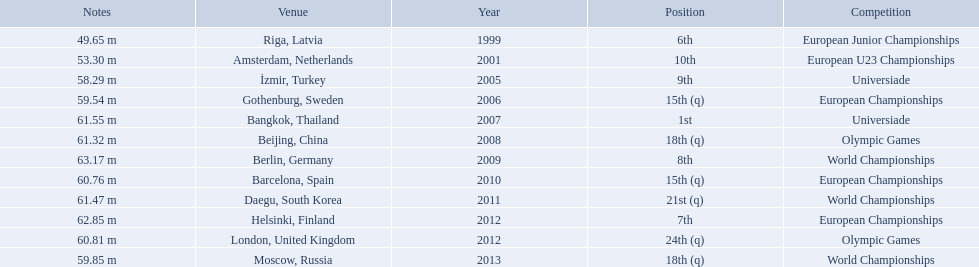What are all the competitions? European Junior Championships, European U23 Championships, Universiade, European Championships, Universiade, Olympic Games, World Championships, European Championships, World Championships, European Championships, Olympic Games, World Championships. What years did they place in the top 10? 1999, 2001, 2005, 2007, 2009, 2012. Besides when they placed first, which position was their highest? 6th. 